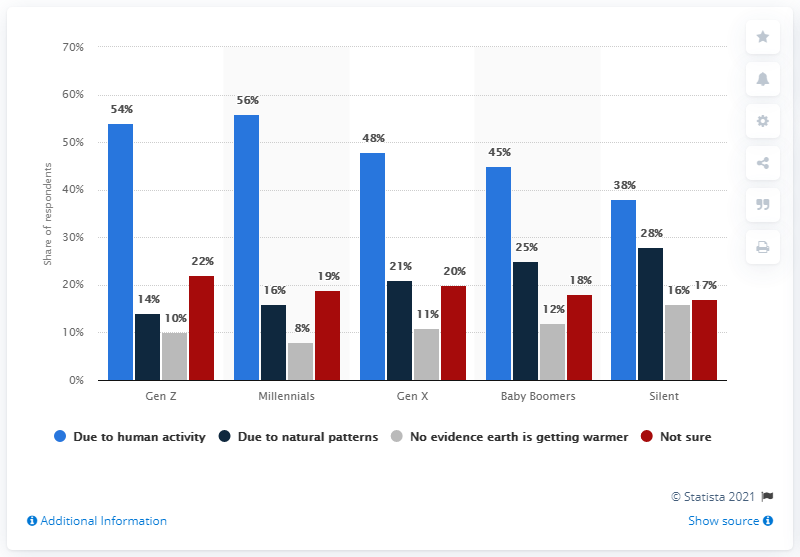Specify some key components in this picture. The most popular response among Gen Z for the impact of human activity on the environment was that it was due to human activity. The most popular response from Gen Z was 44, while the least popular response was 57. 